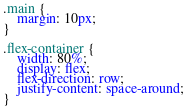<code> <loc_0><loc_0><loc_500><loc_500><_CSS_>.main {
    margin: 10px;
}

.flex-container {
    width: 80%;
    display: flex;
    flex-direction: row;
    justify-content: space-around;
}</code> 